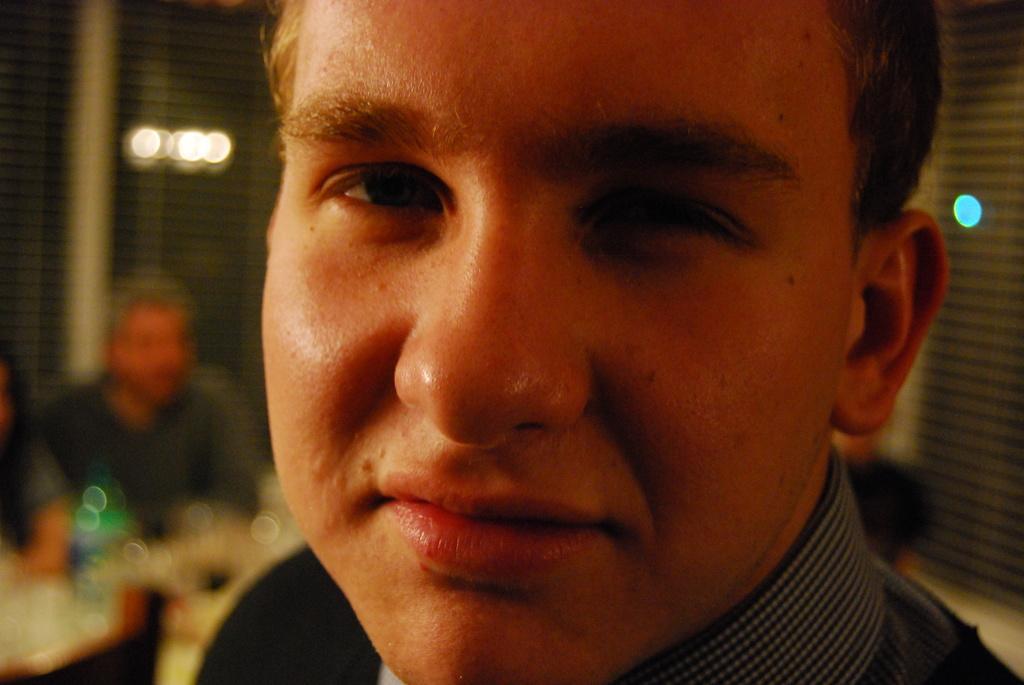Can you describe this image briefly? In this image in front there is a person. Behind him there are few people sitting on the chair. At the backside of the image there are lights. 